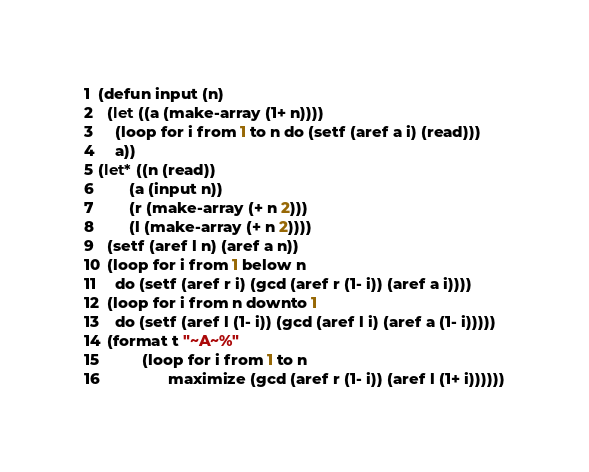<code> <loc_0><loc_0><loc_500><loc_500><_Lisp_>(defun input (n)
  (let ((a (make-array (1+ n))))
    (loop for i from 1 to n do (setf (aref a i) (read)))
    a)) 
(let* ((n (read))
       (a (input n))
       (r (make-array (+ n 2)))
       (l (make-array (+ n 2))))
  (setf (aref l n) (aref a n))
  (loop for i from 1 below n
    do (setf (aref r i) (gcd (aref r (1- i)) (aref a i))))
  (loop for i from n downto 1
    do (setf (aref l (1- i)) (gcd (aref l i) (aref a (1- i)))))
  (format t "~A~%"
          (loop for i from 1 to n
                maximize (gcd (aref r (1- i)) (aref l (1+ i))))))</code> 